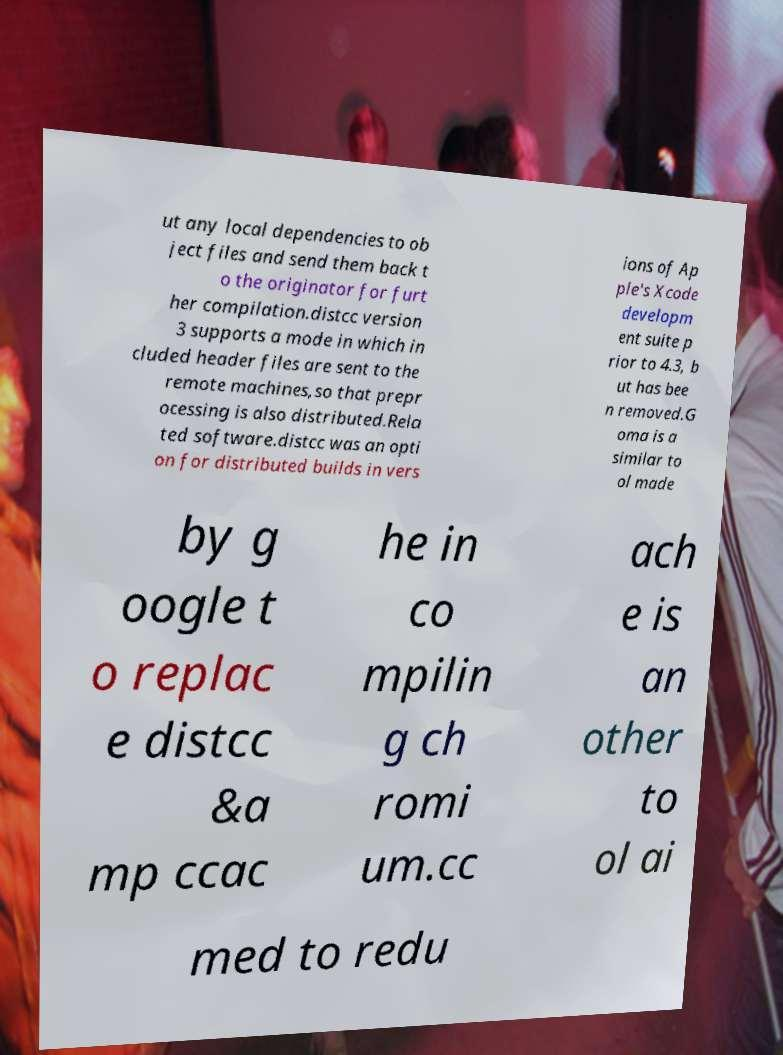Could you assist in decoding the text presented in this image and type it out clearly? ut any local dependencies to ob ject files and send them back t o the originator for furt her compilation.distcc version 3 supports a mode in which in cluded header files are sent to the remote machines,so that prepr ocessing is also distributed.Rela ted software.distcc was an opti on for distributed builds in vers ions of Ap ple's Xcode developm ent suite p rior to 4.3, b ut has bee n removed.G oma is a similar to ol made by g oogle t o replac e distcc &a mp ccac he in co mpilin g ch romi um.cc ach e is an other to ol ai med to redu 